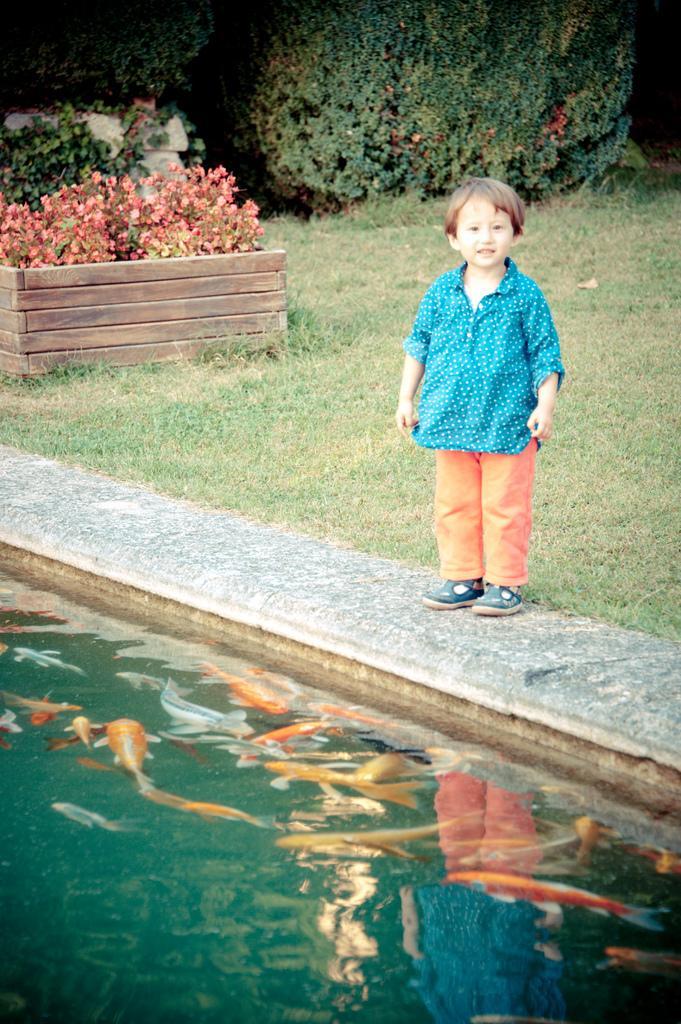Could you give a brief overview of what you see in this image? In this image there is a kid standing on the floor. In front of him there is water in which there are fishes. In the background there are plants. There is a wooden tray in which there are plants with light pink color leaves. 